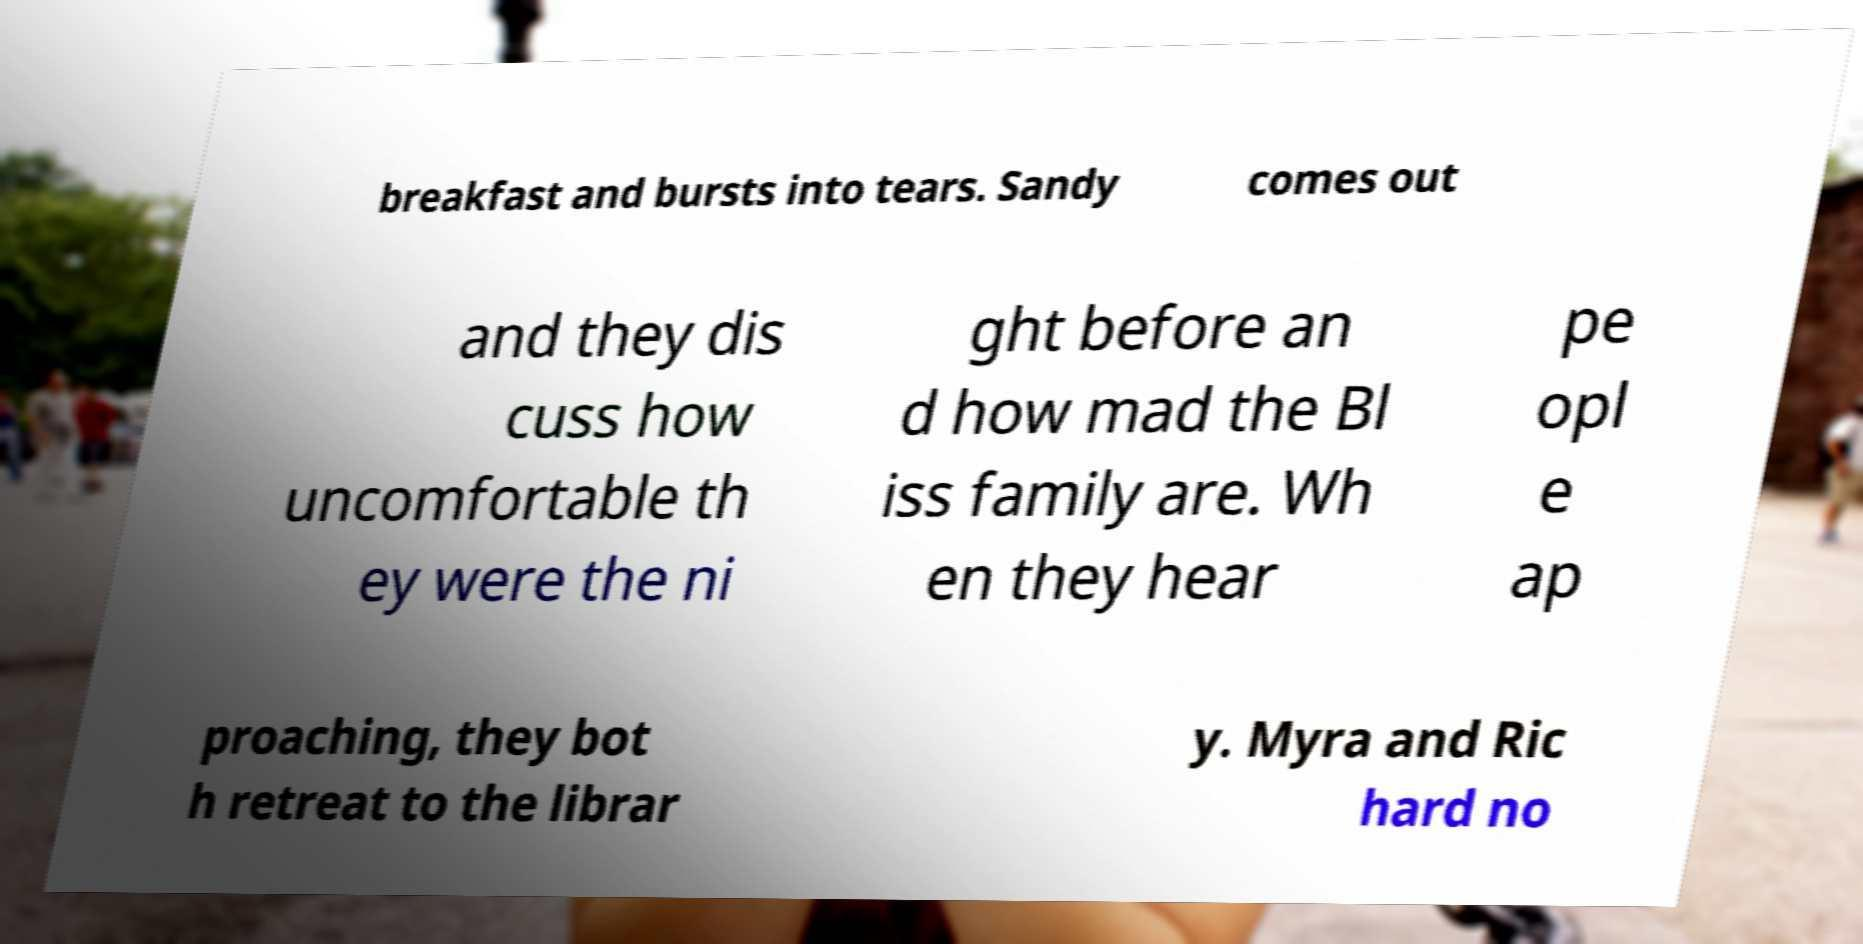There's text embedded in this image that I need extracted. Can you transcribe it verbatim? breakfast and bursts into tears. Sandy comes out and they dis cuss how uncomfortable th ey were the ni ght before an d how mad the Bl iss family are. Wh en they hear pe opl e ap proaching, they bot h retreat to the librar y. Myra and Ric hard no 